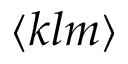<formula> <loc_0><loc_0><loc_500><loc_500>\langle k l m \rangle</formula> 